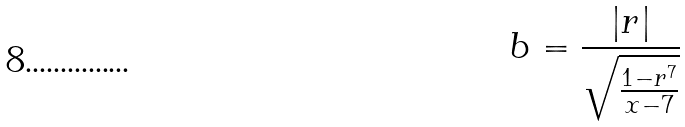<formula> <loc_0><loc_0><loc_500><loc_500>b = \frac { | r | } { \sqrt { \frac { 1 - r ^ { 7 } } { x - 7 } } }</formula> 